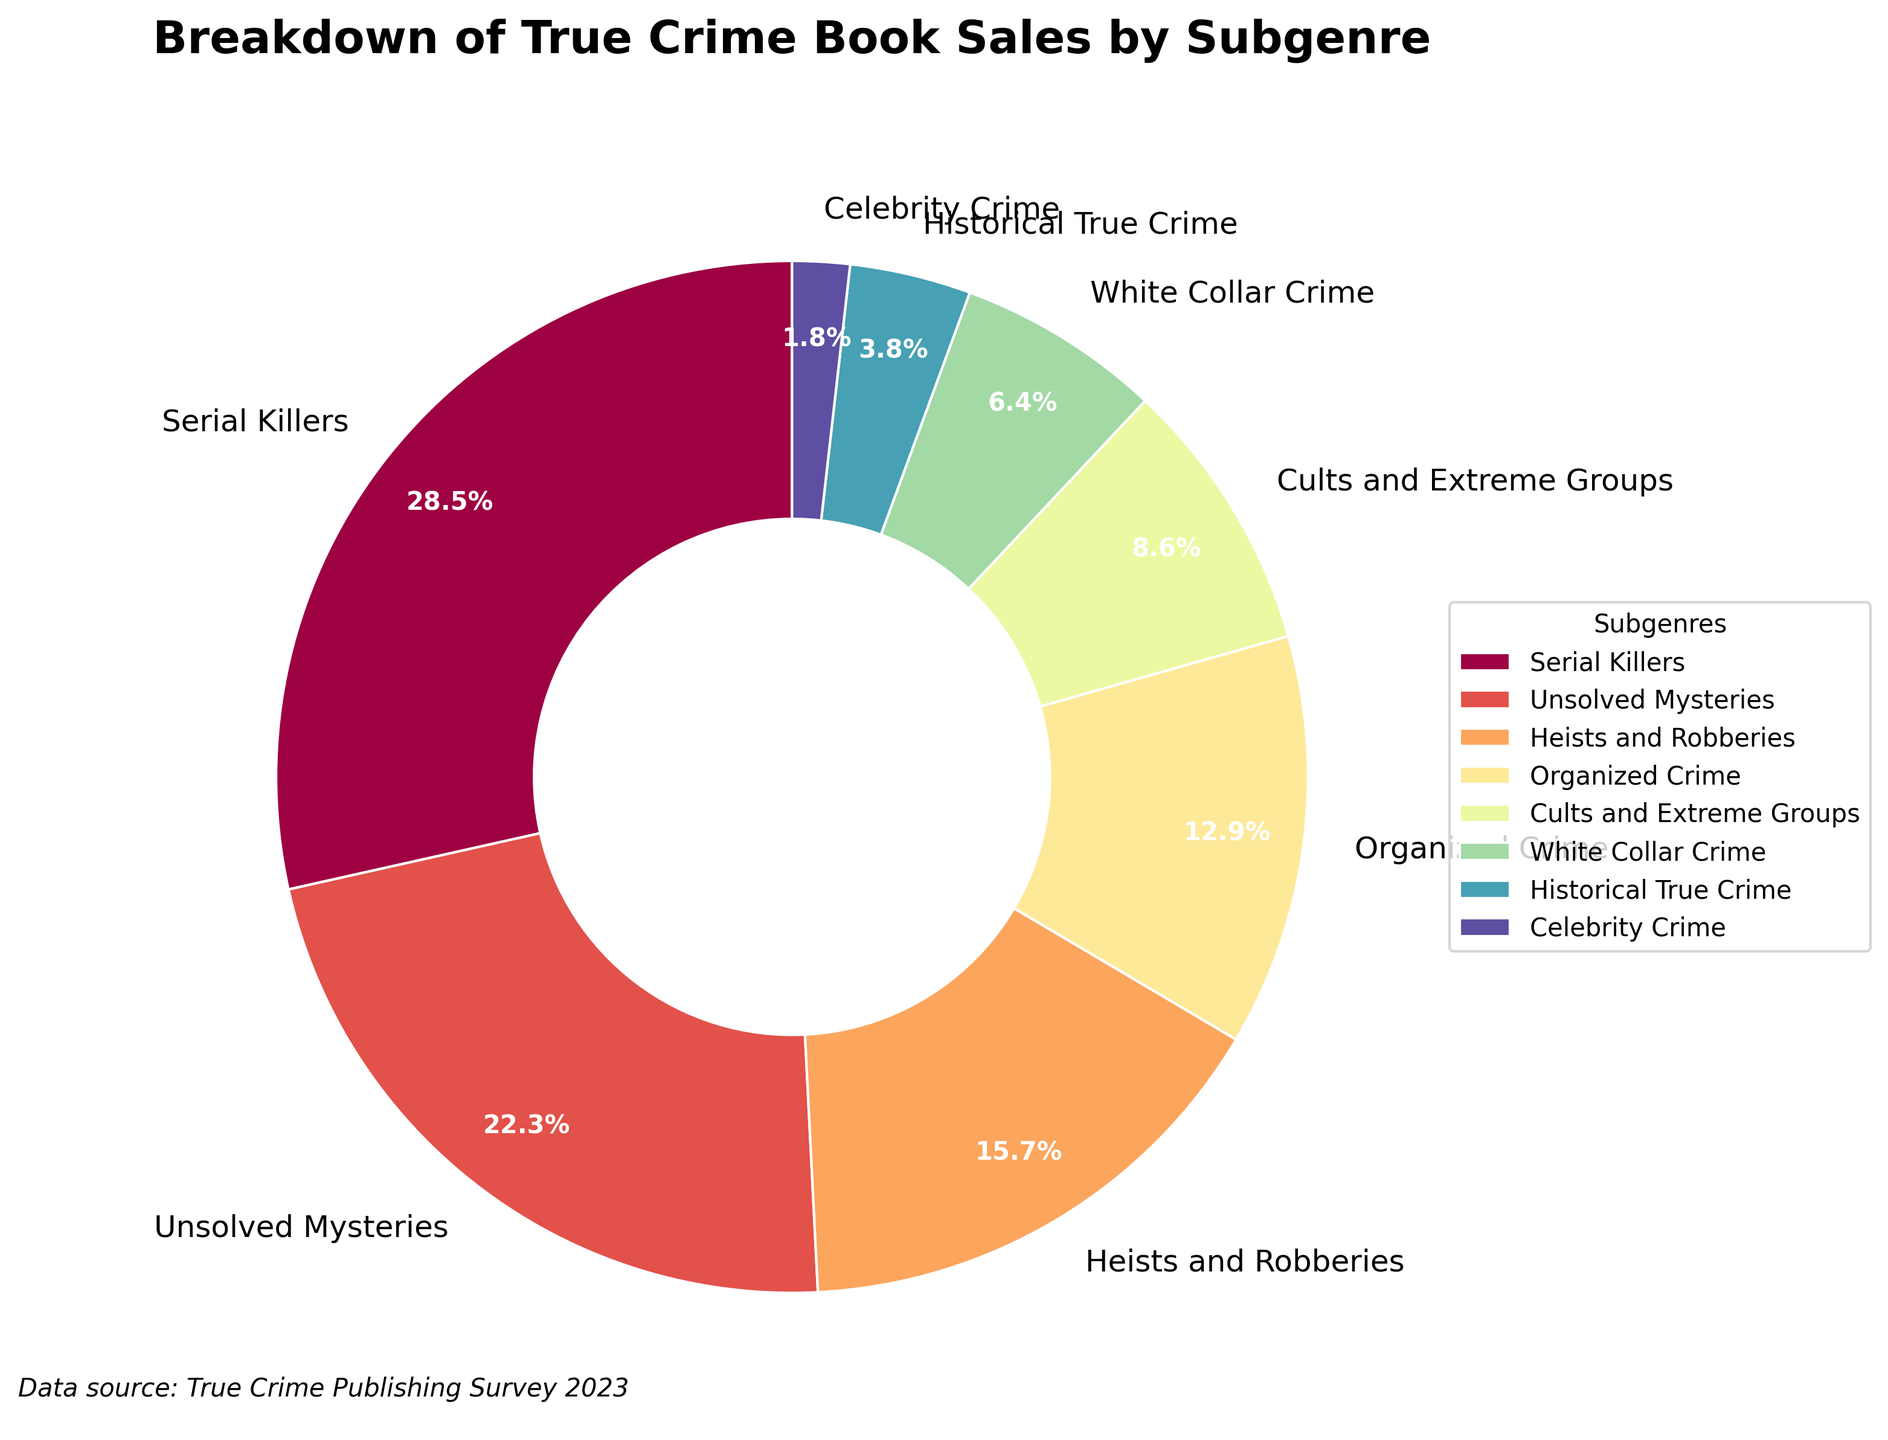Which subgenre has the highest percentage of true crime book sales? By examining the pie chart, you can see that "Serial Killers" occupies the largest segment.
Answer: Serial Killers Which two subgenres combined account for more than 50% of the book sales? The two largest segments in the pie chart are "Serial Killers" with 28.5% and "Unsolved Mysteries" with 22.3%. Adding these two percentages together gives 50.8%, which is more than half.
Answer: Serial Killers and Unsolved Mysteries What is the difference in percentage between "Heists and Robberies" and "Historical True Crime"? Find the respective percentages for "Heists and Robberies" (15.7%) and "Historical True Crime" (3.8%) and subtract the smaller from the larger. Thus, 15.7% - 3.8% = 11.9%.
Answer: 11.9% How do the percentages of "Organized Crime" and "Cults and Extreme Groups" compare? Compare the slices of "Organized Crime" at 12.9% and "Cults and Extreme Groups" at 8.6%, determining that "Organized Crime" has a larger percentage.
Answer: Organized Crime is higher What is the total percentage of book sales for subgenres with percentages less than 10%? Identify the subgenres with percentages less than 10%: "Cults and Extreme Groups" (8.6%), "White Collar Crime" (6.4%), "Historical True Crime" (3.8%), and "Celebrity Crime" (1.8%). Adding these values: 8.6% + 6.4% + 3.8% + 1.8% = 20.6%.
Answer: 20.6% Which subgenre has the smallest segment on the pie chart? Look for the smallest segment in the chart, which corresponds to "Celebrity Crime" with 1.8%.
Answer: Celebrity Crime What is the sum percentage of "Organized Crime" and "White Collar Crime"? Add the percentages for "Organized Crime" (12.9%) and "White Collar Crime" (6.4%) together: 12.9% + 6.4% = 19.3%.
Answer: 19.3% Which subgenre's segment has a percentage closest to 20%? Identify the segment closest to 20%, which is "Unsolved Mysteries" at 22.3%.
Answer: Unsolved Mysteries Between "Heists and Robberies" and "Cults and Extreme Groups," which has a larger slice, and by how much? Compare the percentages of "Heists and Robberies" (15.7%) and "Cults and Extreme Groups" (8.6%). The difference is 15.7% - 8.6% = 7.1%.
Answer: Heists and Robberies by 7.1% If you combine "Historical True Crime" and "Celebrity Crime," would their total percentage be more or less than "White Collar Crime"? Combine the percentages of "Historical True Crime" (3.8%) and "Celebrity Crime" (1.8%): 3.8% + 1.8% = 5.6%. Compare this to "White Collar Crime" at 6.4%.
Answer: Less 